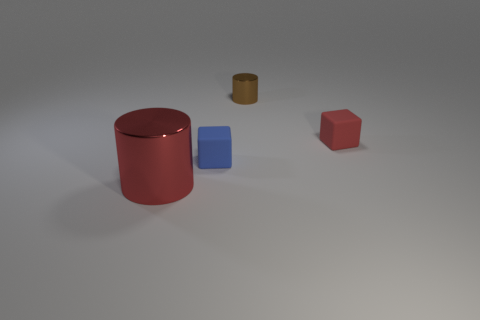There is a cylinder to the right of the cylinder that is to the left of the metallic cylinder that is behind the blue matte object; what is its color?
Provide a short and direct response. Brown. There is a metal object in front of the red block; does it have the same color as the tiny rubber block right of the brown shiny cylinder?
Your response must be concise. Yes. The small matte thing that is in front of the red rubber object right of the small blue thing is what shape?
Keep it short and to the point. Cube. Are there any cyan rubber balls of the same size as the blue matte block?
Give a very brief answer. No. How many brown objects have the same shape as the big red thing?
Offer a very short reply. 1. Are there the same number of brown metallic objects on the left side of the large thing and blue objects that are on the left side of the brown metallic cylinder?
Offer a very short reply. No. Are any small brown cylinders visible?
Keep it short and to the point. Yes. How big is the metal cylinder that is to the right of the small rubber cube to the left of the cylinder right of the big thing?
Give a very brief answer. Small. There is a blue matte object that is the same size as the red cube; what is its shape?
Give a very brief answer. Cube. What number of objects are small blocks that are right of the blue rubber object or small cylinders?
Make the answer very short. 2. 